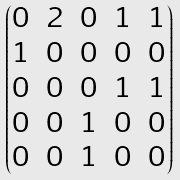Convert formula to latex. <formula><loc_0><loc_0><loc_500><loc_500>\begin{pmatrix} 0 & 2 & 0 & 1 & 1 \\ 1 & 0 & 0 & 0 & 0 \\ 0 & 0 & 0 & 1 & 1 \\ 0 & 0 & 1 & 0 & 0 \\ 0 & 0 & 1 & 0 & 0 \end{pmatrix}</formula> 